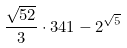Convert formula to latex. <formula><loc_0><loc_0><loc_500><loc_500>\frac { \sqrt { 5 2 } } { 3 } \cdot 3 4 1 - 2 ^ { \sqrt { 5 } }</formula> 